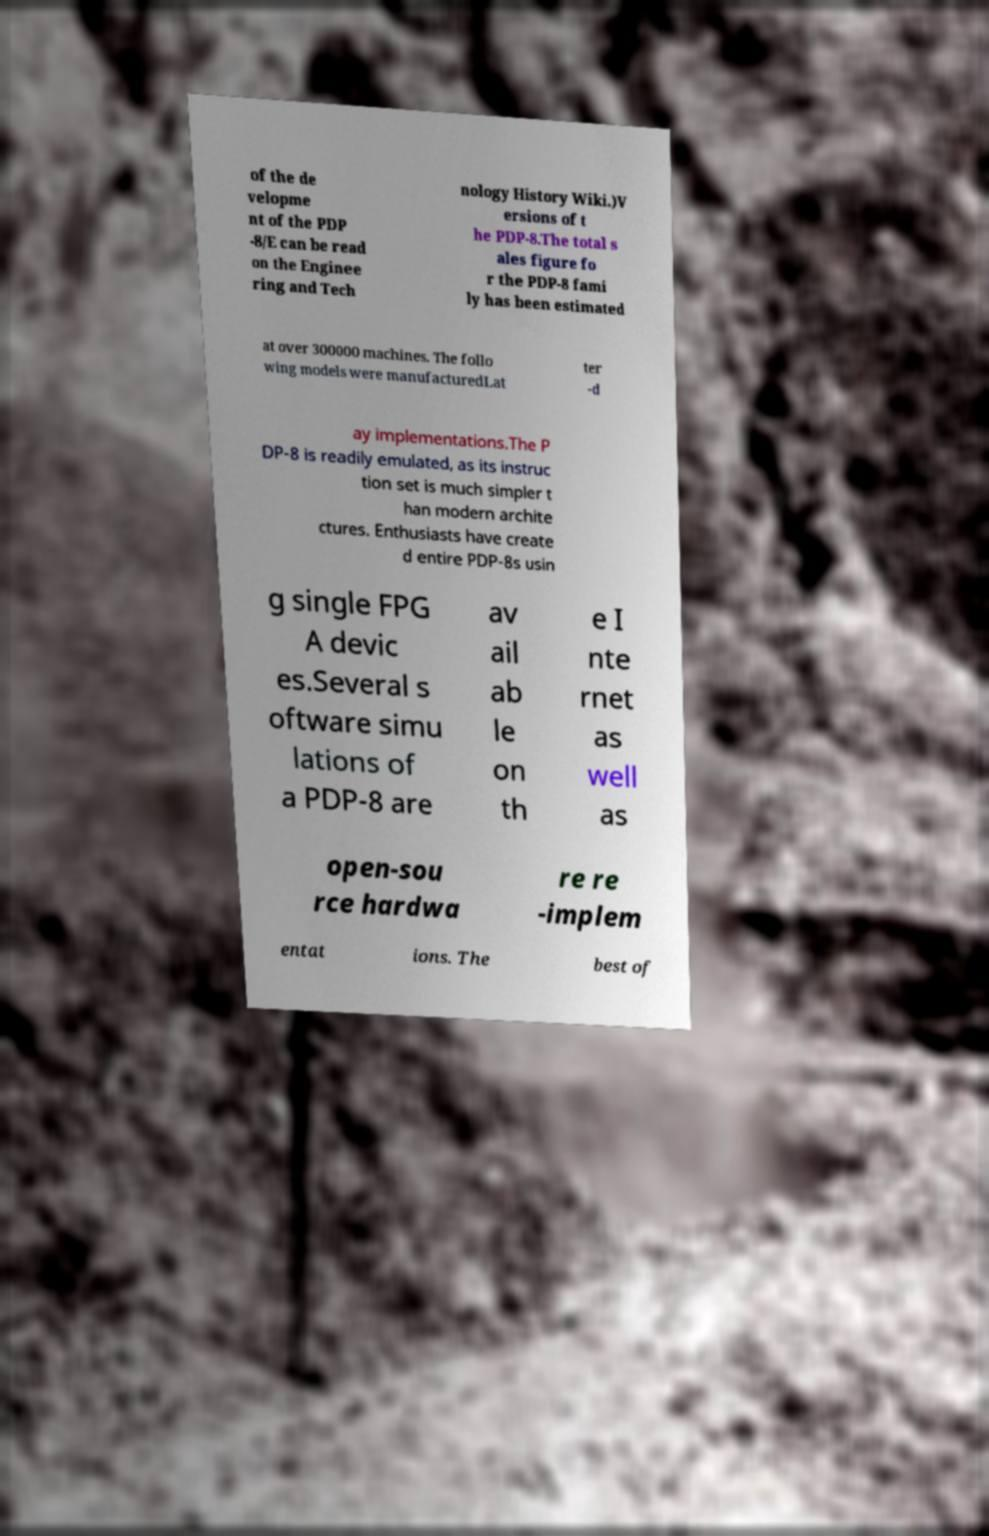For documentation purposes, I need the text within this image transcribed. Could you provide that? of the de velopme nt of the PDP -8/E can be read on the Enginee ring and Tech nology History Wiki.)V ersions of t he PDP-8.The total s ales figure fo r the PDP-8 fami ly has been estimated at over 300000 machines. The follo wing models were manufacturedLat ter -d ay implementations.The P DP-8 is readily emulated, as its instruc tion set is much simpler t han modern archite ctures. Enthusiasts have create d entire PDP-8s usin g single FPG A devic es.Several s oftware simu lations of a PDP-8 are av ail ab le on th e I nte rnet as well as open-sou rce hardwa re re -implem entat ions. The best of 